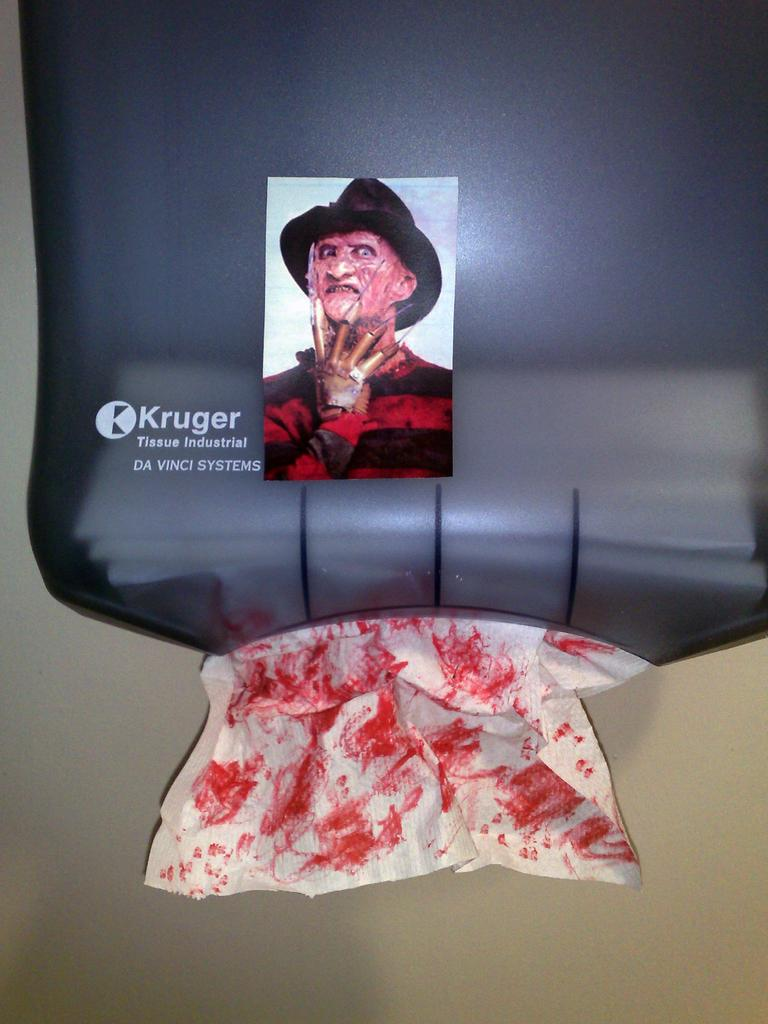What object can be seen in the image that holds tissues? There is a tissue holder in the image. Is there any decoration or image on the tissue holder? Yes, there is a picture of a person on top of the tissue holder. How does the tissue holder contribute to the growth of plants in the image? The tissue holder does not contribute to the growth of plants in the image, as it is an object designed to hold tissues. 